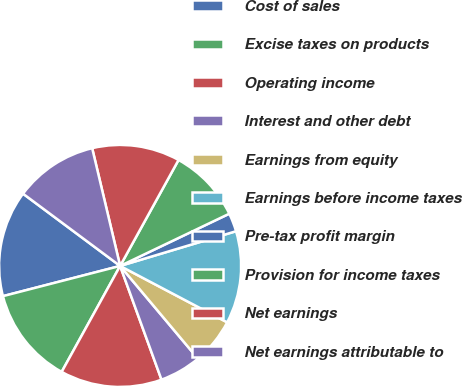Convert chart. <chart><loc_0><loc_0><loc_500><loc_500><pie_chart><fcel>Cost of sales<fcel>Excise taxes on products<fcel>Operating income<fcel>Interest and other debt<fcel>Earnings from equity<fcel>Earnings before income taxes<fcel>Pre-tax profit margin<fcel>Provision for income taxes<fcel>Net earnings<fcel>Net earnings attributable to<nl><fcel>14.2%<fcel>12.96%<fcel>13.58%<fcel>5.56%<fcel>6.17%<fcel>12.35%<fcel>2.47%<fcel>9.88%<fcel>11.73%<fcel>11.11%<nl></chart> 